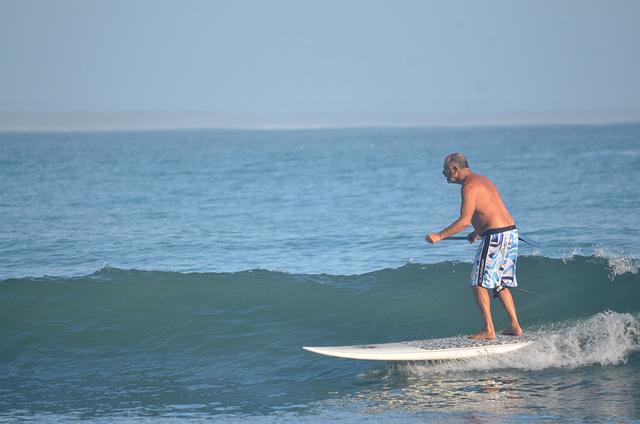Is the person wearing a hat?
Keep it brief. No. What is the man riding?
Answer briefly. Surfboard. What color are the men's swim trunks?
Be succinct. Blue and white. Is this man hugging the waves?
Answer briefly. No. What is on this person's finger?
Concise answer only. Paddle. Would you say the water is salty?
Keep it brief. Yes. How many people are on that surfboard?
Concise answer only. 1. 